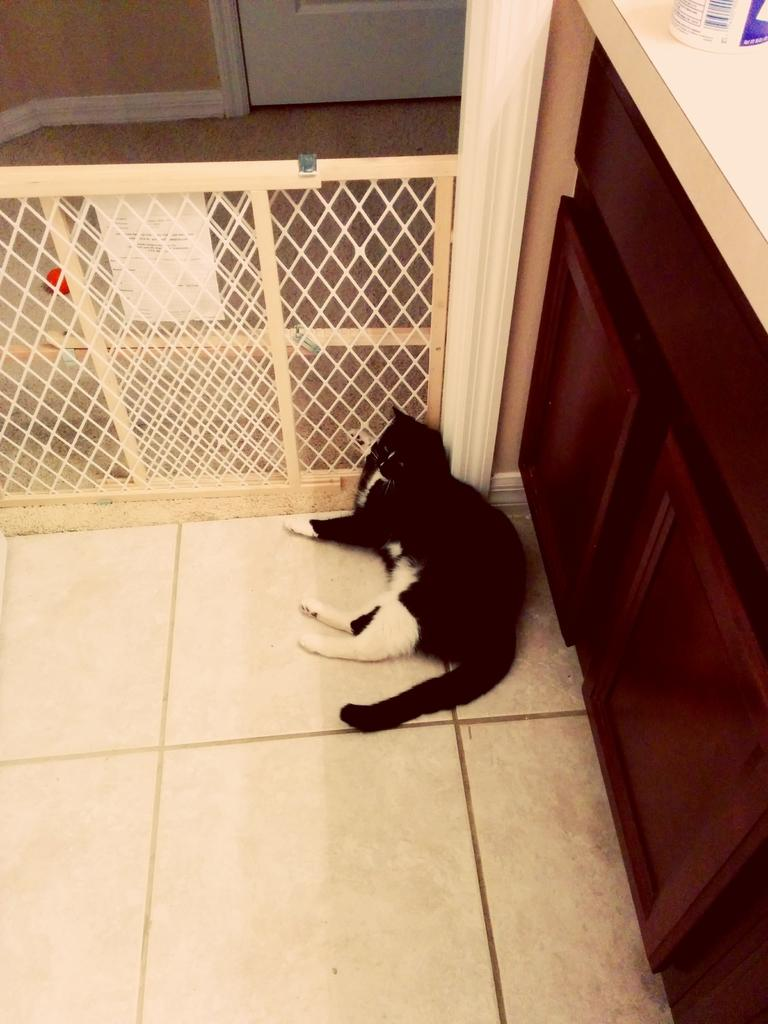What type of animal is lying on the floor in the image? There is a cat lying on the floor in the image. What is near the cat in the image? There is a wooden railing near the cat. What furniture can be seen on the right side of the image? There is a table with cupboards on the right side of the image. What type of rock is visible in the image? There is no rock present in the image. 